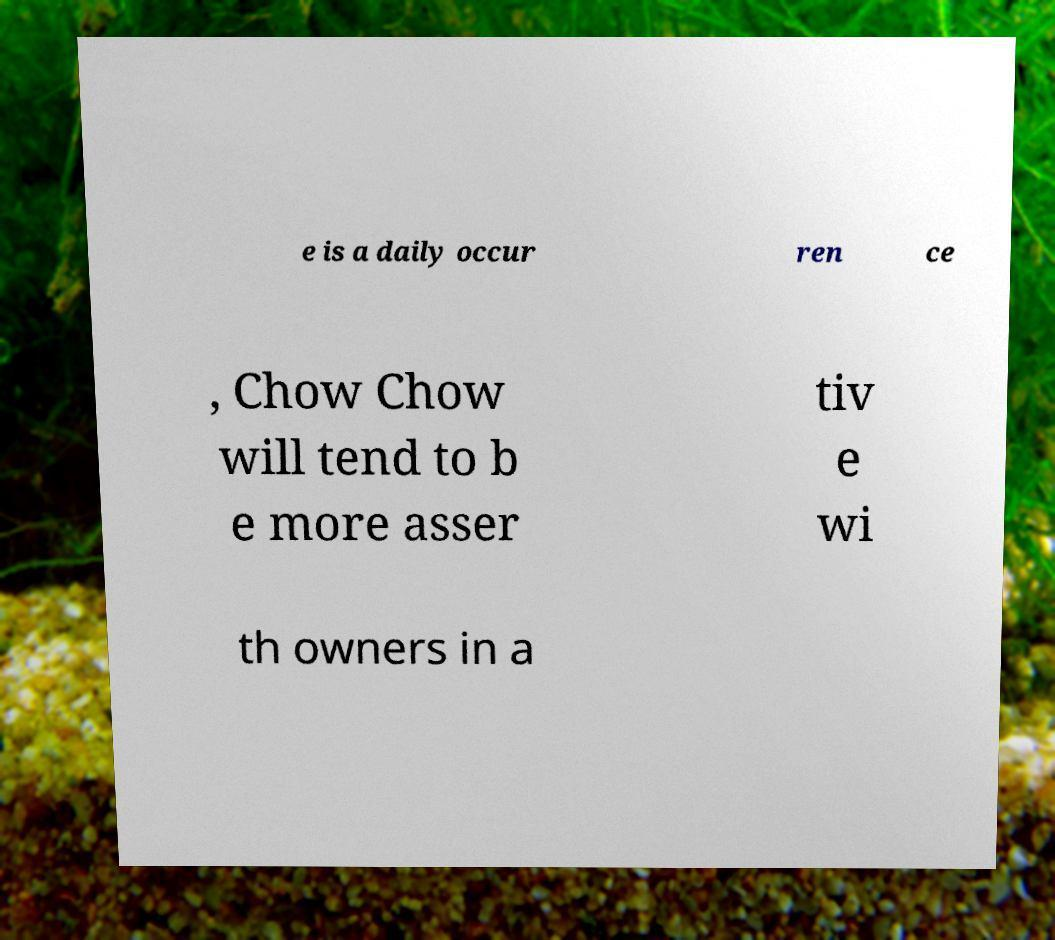What messages or text are displayed in this image? I need them in a readable, typed format. e is a daily occur ren ce , Chow Chow will tend to b e more asser tiv e wi th owners in a 